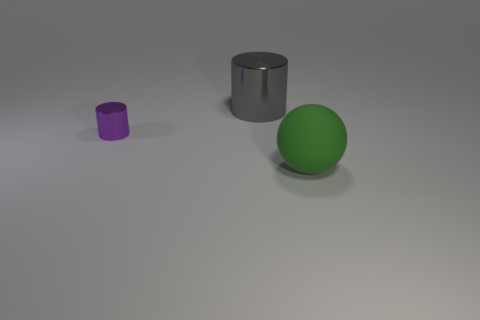Are there more big blue rubber cubes than purple cylinders?
Give a very brief answer. No. Are there any other things of the same color as the tiny object?
Offer a terse response. No. Is the material of the tiny purple thing the same as the large ball?
Your answer should be compact. No. Is the number of tiny blue metallic things less than the number of large objects?
Your answer should be compact. Yes. Is the green thing the same shape as the small purple object?
Provide a succinct answer. No. The small shiny thing has what color?
Your response must be concise. Purple. How many other things are made of the same material as the green ball?
Offer a terse response. 0. How many green objects are either large matte spheres or small metal cylinders?
Offer a terse response. 1. There is a shiny thing that is to the right of the purple metal cylinder; is it the same shape as the large object that is in front of the tiny purple shiny thing?
Your answer should be very brief. No. Do the rubber ball and the metallic cylinder on the right side of the tiny shiny cylinder have the same color?
Keep it short and to the point. No. 